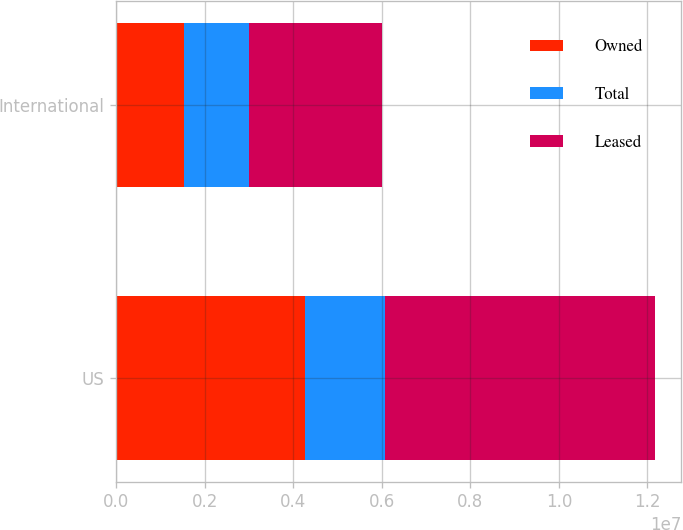Convert chart. <chart><loc_0><loc_0><loc_500><loc_500><stacked_bar_chart><ecel><fcel>US<fcel>International<nl><fcel>Owned<fcel>4.256e+06<fcel>1.522e+06<nl><fcel>Total<fcel>1.824e+06<fcel>1.483e+06<nl><fcel>Leased<fcel>6.08e+06<fcel>3.005e+06<nl></chart> 